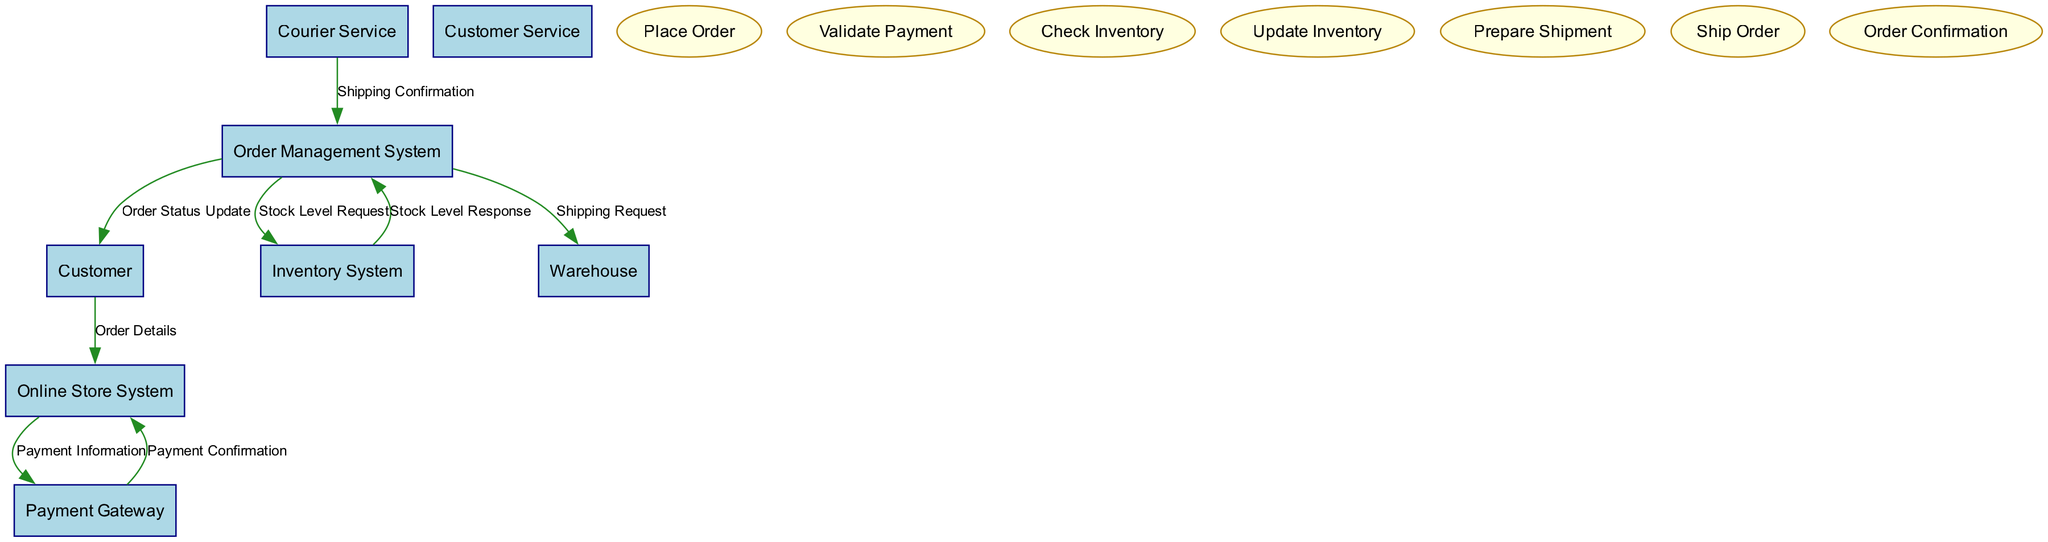What is the total number of entities in the diagram? The diagram includes eight entities, which are Customer, Online Store System, Order Management System, Inventory System, Payment Gateway, Warehouse, Courier Service, and Customer Service.
Answer: eight What is the process that verifies customer payment? The diagram specifies that the "Validate Payment" process is responsible for verifying and processing the customer’s payment.
Answer: Validate Payment Which entity receives the "Order Details"? According to the diagram, the "Online Store System" receives the "Order Details" from the "Customer."
Answer: Online Store System How many processes are depicted in the diagram? There are seven processes shown in the diagram: Place Order, Validate Payment, Check Inventory, Update Inventory, Prepare Shipment, Ship Order, and Order Confirmation.
Answer: seven Which system sends the "Shipping Request" to the Warehouse? The diagram shows that the "Order Management System" sends the "Shipping Request" to the Warehouse to prepare for shipping.
Answer: Order Management System What happens after the "Payment Confirmation" is received? Following the "Payment Confirmation" from the "Payment Gateway," the "Online Store System" moves to notify the customer about the order status, demonstrating a direct sequence of processes post-payment confirmation.
Answer: Order Status Update Which entity is responsible for packing items for delivery? The diagram indicates that the "Warehouse" is tasked with packing and preparing the items based on requests from the "Order Management System."
Answer: Warehouse Which data flow indicates the stock level response from the Inventory System? The "Stock Level Response" data flow is the one that indicates the availability status of items from the Inventory System back to the Order Management System.
Answer: Stock Level Response What is the relationship between the Order Management System and Customer? The relationship is shown through the "Order Status Update," which flows from the Order Management System to the Customer to inform them of order updates.
Answer: Order Status Update 